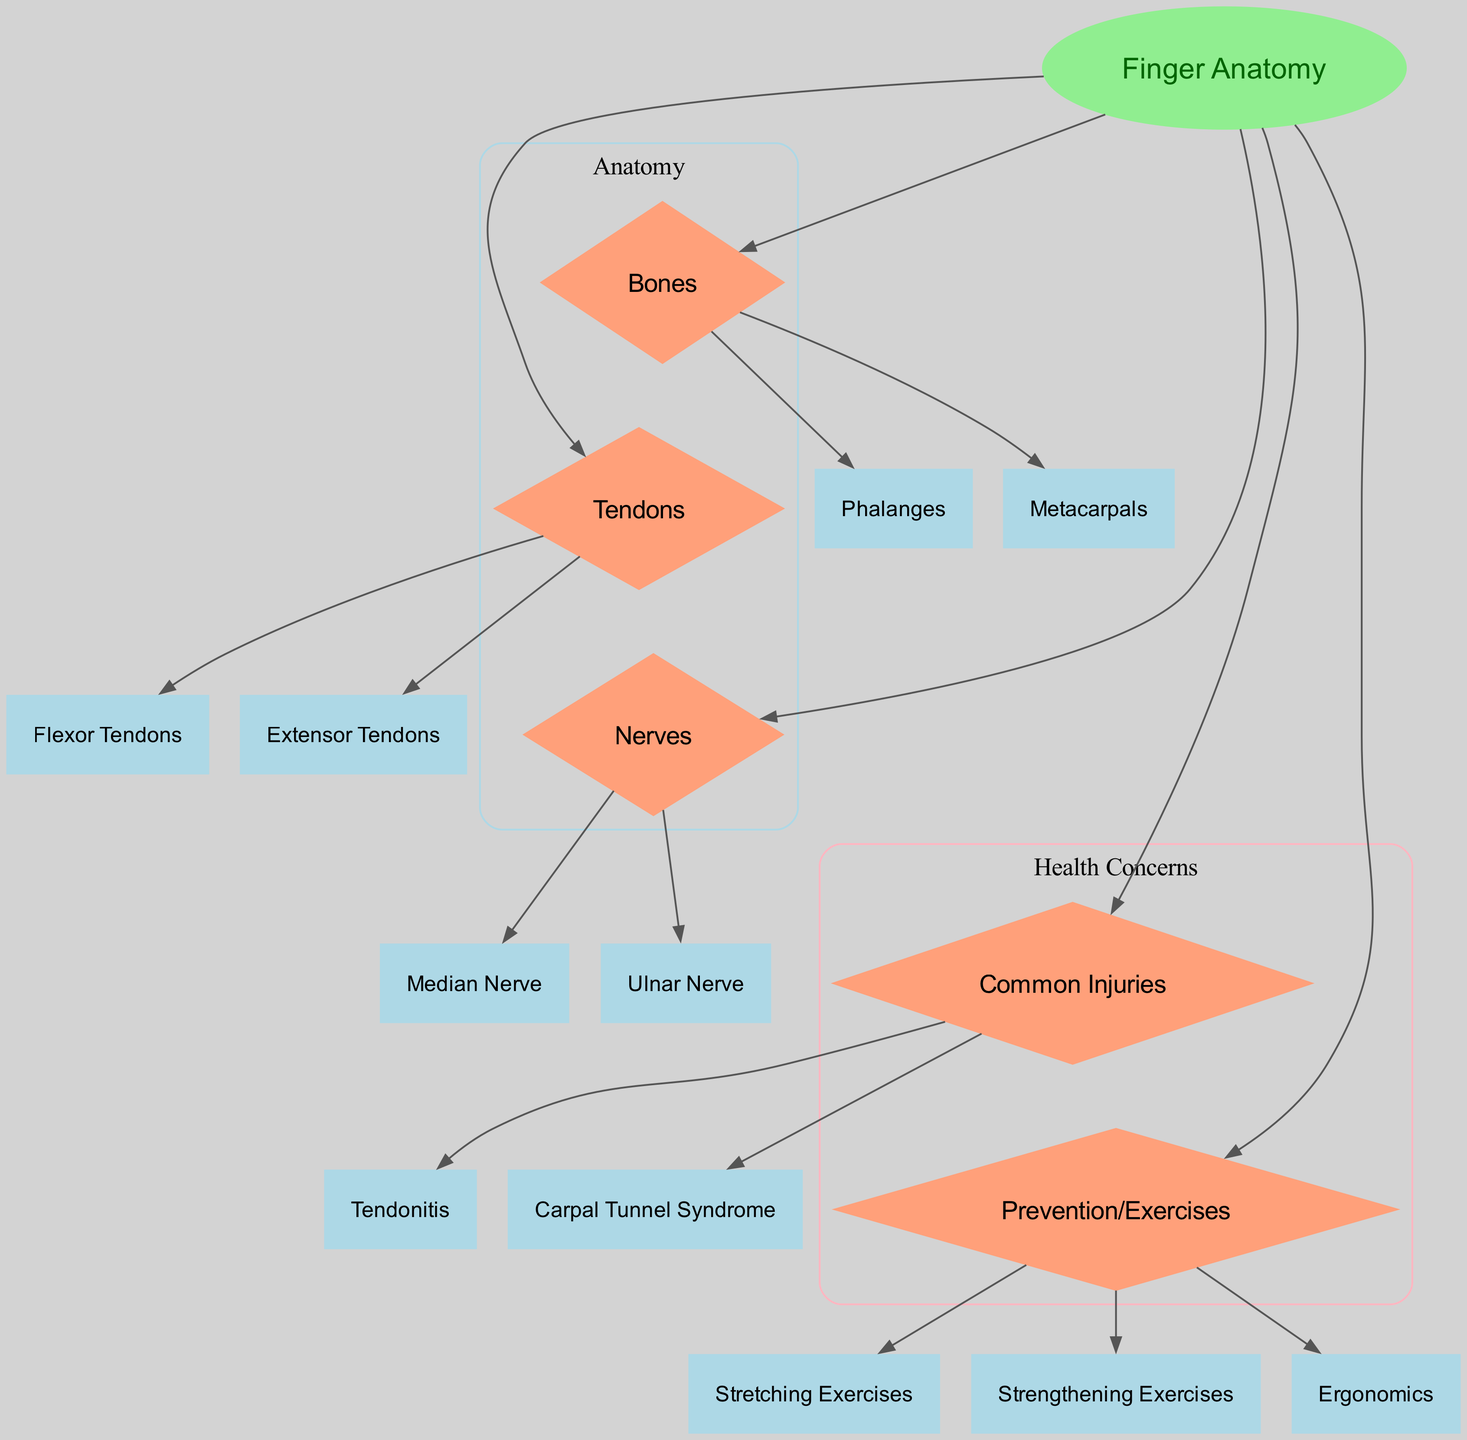What is the main focus of the diagram? The diagram centers on "Finger Anatomy and Injury Prevention," highlighting the anatomy of fingers, associated injuries, and preventative measures.
Answer: Finger Anatomy and Injury Prevention How many types of bones are identified in the diagram? The diagram identifies two types of bones related to finger anatomy: "Phalanges" and "Metacarpals." This is derived from the nodes connected to "Bones."
Answer: 2 Which tendons are presented in the diagram? The diagram features two types of tendons: "Flexor Tendons" and "Extensor Tendons." These are directly connected to the "Tendons" node in the diagram.
Answer: Flexor Tendons, Extensor Tendons What are the two common injuries listed in the diagram? The diagram lists "Tendonitis" and "Carpal Tunnel Syndrome" as common injuries that are linked to the overall structure of finger anatomy and their functions.
Answer: Tendonitis, Carpal Tunnel Syndrome How many preventative measures are indicated in the diagram? The diagram indicates three preventative measures: "Stretching Exercises," "Strengthening Exercises," and "Ergonomics." These nodes are directly associated with the "Prevention" section of the diagram.
Answer: 3 Which nerve is specifically highlighted that relates to carpal tunnel syndrome? The "Median Nerve" is specifically highlighted in the diagram, as it is commonly associated with carpal tunnel syndrome, illustrated by its connection to the "Nerves" section.
Answer: Median Nerve What does the "Ergonomics" node connect to? The "Ergonomics" node is part of the "Prevention" section, which indicates its connection to overall preventative strategies against injuries related to finger anatomy in the diagram.
Answer: Prevention Which structures are directly related to injuries in the context of this diagram? The structures directly related to injuries are "Tendons" and "Nerves," with specific injuries listed, such as "Tendonitis" and "Carpal Tunnel Syndrome," showing how various elements interconnect positing finger injuries.
Answer: Tendons, Nerves What are the overall categories represented in the diagram? The diagram presents three main categories: "Anatomy," "Health Concerns," and "Injuries," organized into clusters to aid understanding of the relationships.
Answer: Anatomy, Health Concerns, Injuries 